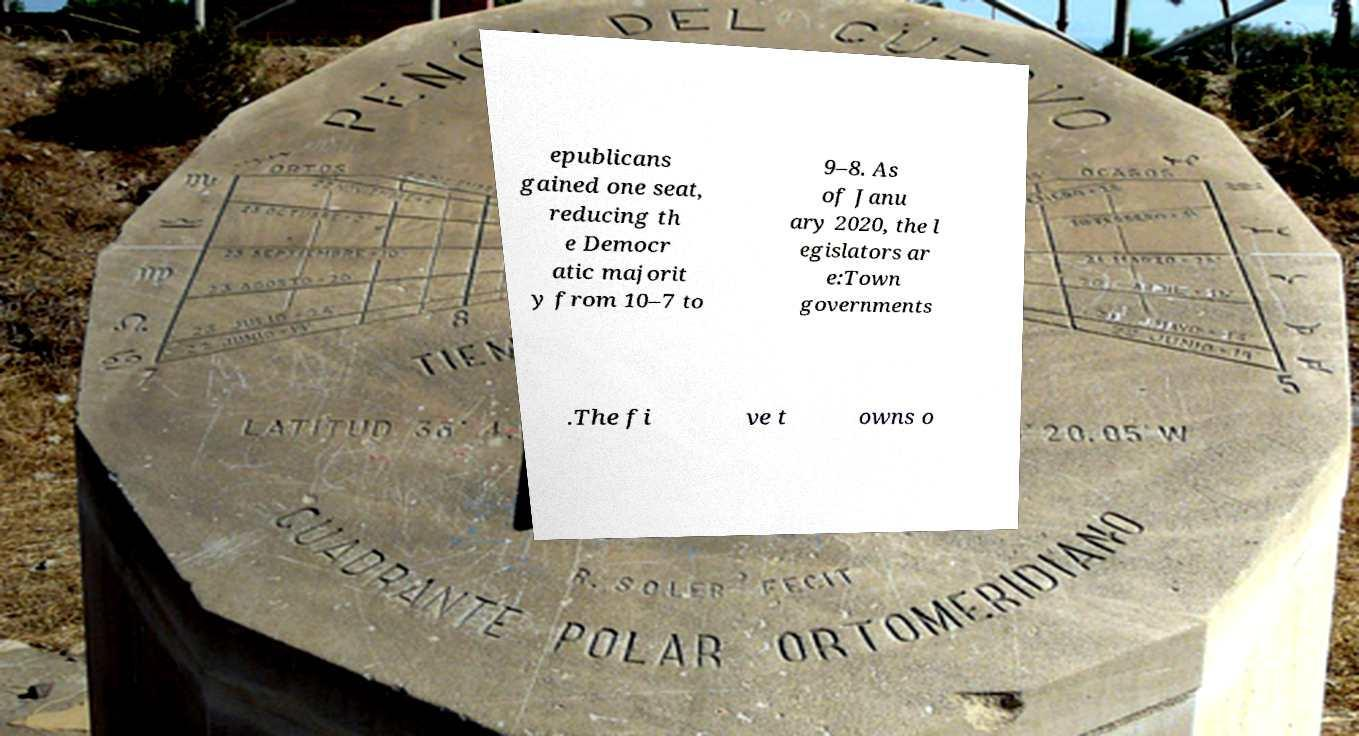There's text embedded in this image that I need extracted. Can you transcribe it verbatim? epublicans gained one seat, reducing th e Democr atic majorit y from 10–7 to 9–8. As of Janu ary 2020, the l egislators ar e:Town governments .The fi ve t owns o 